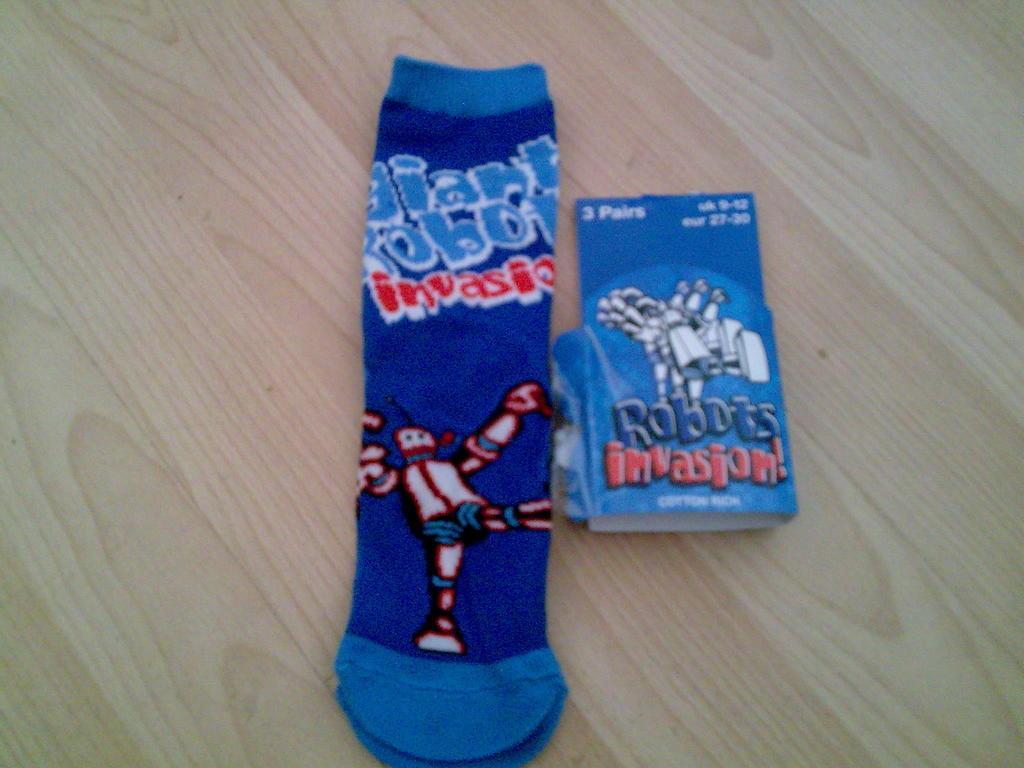How would you summarize this image in a sentence or two? In this picture we can see a sock, robot is printed on it and aside to that it is a card where the sock is removed from this card and this both are placed on the table. 